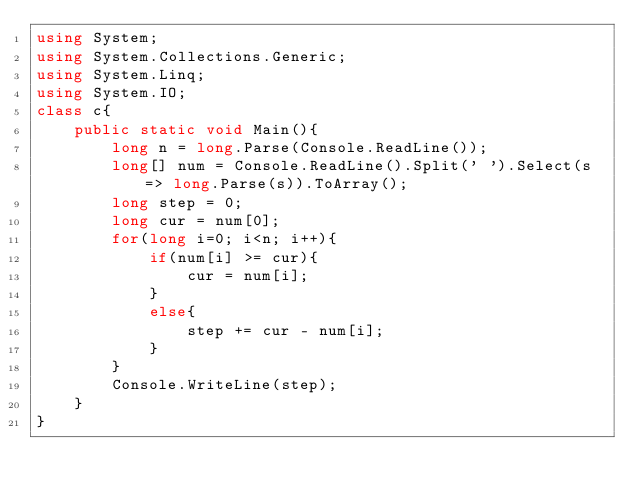Convert code to text. <code><loc_0><loc_0><loc_500><loc_500><_C#_>using System;
using System.Collections.Generic;
using System.Linq;
using System.IO;
class c{
    public static void Main(){
        long n = long.Parse(Console.ReadLine());
        long[] num = Console.ReadLine().Split(' ').Select(s => long.Parse(s)).ToArray();
        long step = 0;
        long cur = num[0];
        for(long i=0; i<n; i++){
            if(num[i] >= cur){
                cur = num[i];
            }
            else{
                step += cur - num[i];
            }
        }
        Console.WriteLine(step);
    }
}
</code> 